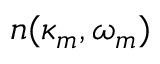<formula> <loc_0><loc_0><loc_500><loc_500>n ( \kappa _ { m } , \omega _ { m } )</formula> 